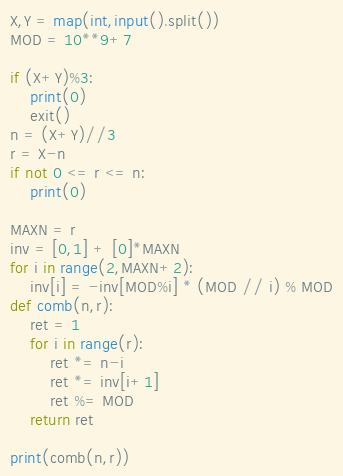Convert code to text. <code><loc_0><loc_0><loc_500><loc_500><_Python_>X,Y = map(int,input().split())
MOD = 10**9+7

if (X+Y)%3:
    print(0)
    exit()
n = (X+Y)//3
r = X-n
if not 0 <= r <= n:
    print(0)

MAXN = r
inv = [0,1] + [0]*MAXN
for i in range(2,MAXN+2):
    inv[i] = -inv[MOD%i] * (MOD // i) % MOD
def comb(n,r):
    ret = 1
    for i in range(r):
        ret *= n-i
        ret *= inv[i+1]
        ret %= MOD
    return ret

print(comb(n,r))</code> 